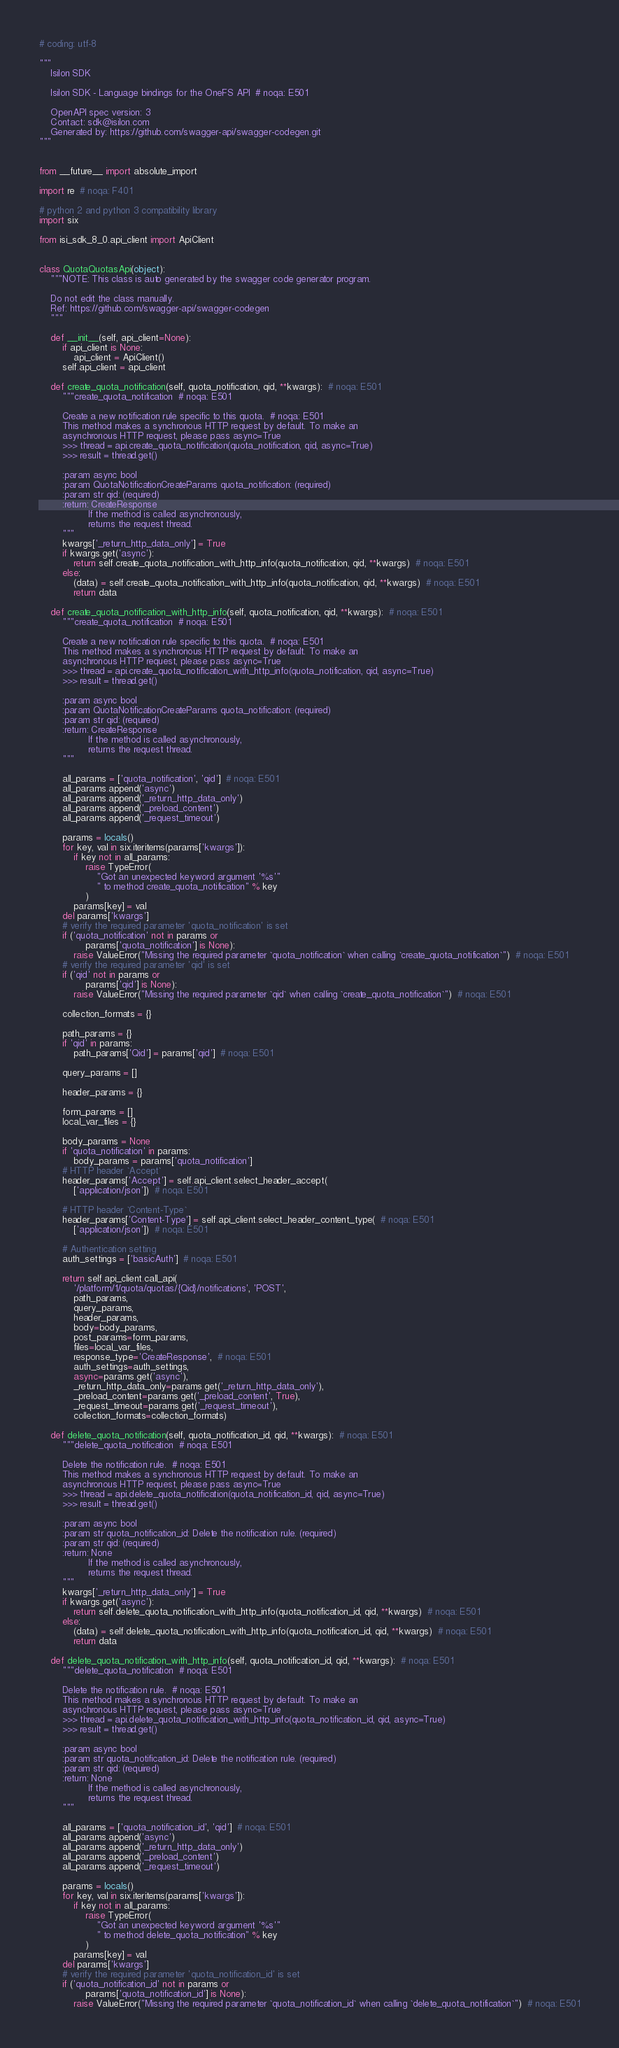Convert code to text. <code><loc_0><loc_0><loc_500><loc_500><_Python_># coding: utf-8

"""
    Isilon SDK

    Isilon SDK - Language bindings for the OneFS API  # noqa: E501

    OpenAPI spec version: 3
    Contact: sdk@isilon.com
    Generated by: https://github.com/swagger-api/swagger-codegen.git
"""


from __future__ import absolute_import

import re  # noqa: F401

# python 2 and python 3 compatibility library
import six

from isi_sdk_8_0.api_client import ApiClient


class QuotaQuotasApi(object):
    """NOTE: This class is auto generated by the swagger code generator program.

    Do not edit the class manually.
    Ref: https://github.com/swagger-api/swagger-codegen
    """

    def __init__(self, api_client=None):
        if api_client is None:
            api_client = ApiClient()
        self.api_client = api_client

    def create_quota_notification(self, quota_notification, qid, **kwargs):  # noqa: E501
        """create_quota_notification  # noqa: E501

        Create a new notification rule specific to this quota.  # noqa: E501
        This method makes a synchronous HTTP request by default. To make an
        asynchronous HTTP request, please pass async=True
        >>> thread = api.create_quota_notification(quota_notification, qid, async=True)
        >>> result = thread.get()

        :param async bool
        :param QuotaNotificationCreateParams quota_notification: (required)
        :param str qid: (required)
        :return: CreateResponse
                 If the method is called asynchronously,
                 returns the request thread.
        """
        kwargs['_return_http_data_only'] = True
        if kwargs.get('async'):
            return self.create_quota_notification_with_http_info(quota_notification, qid, **kwargs)  # noqa: E501
        else:
            (data) = self.create_quota_notification_with_http_info(quota_notification, qid, **kwargs)  # noqa: E501
            return data

    def create_quota_notification_with_http_info(self, quota_notification, qid, **kwargs):  # noqa: E501
        """create_quota_notification  # noqa: E501

        Create a new notification rule specific to this quota.  # noqa: E501
        This method makes a synchronous HTTP request by default. To make an
        asynchronous HTTP request, please pass async=True
        >>> thread = api.create_quota_notification_with_http_info(quota_notification, qid, async=True)
        >>> result = thread.get()

        :param async bool
        :param QuotaNotificationCreateParams quota_notification: (required)
        :param str qid: (required)
        :return: CreateResponse
                 If the method is called asynchronously,
                 returns the request thread.
        """

        all_params = ['quota_notification', 'qid']  # noqa: E501
        all_params.append('async')
        all_params.append('_return_http_data_only')
        all_params.append('_preload_content')
        all_params.append('_request_timeout')

        params = locals()
        for key, val in six.iteritems(params['kwargs']):
            if key not in all_params:
                raise TypeError(
                    "Got an unexpected keyword argument '%s'"
                    " to method create_quota_notification" % key
                )
            params[key] = val
        del params['kwargs']
        # verify the required parameter 'quota_notification' is set
        if ('quota_notification' not in params or
                params['quota_notification'] is None):
            raise ValueError("Missing the required parameter `quota_notification` when calling `create_quota_notification`")  # noqa: E501
        # verify the required parameter 'qid' is set
        if ('qid' not in params or
                params['qid'] is None):
            raise ValueError("Missing the required parameter `qid` when calling `create_quota_notification`")  # noqa: E501

        collection_formats = {}

        path_params = {}
        if 'qid' in params:
            path_params['Qid'] = params['qid']  # noqa: E501

        query_params = []

        header_params = {}

        form_params = []
        local_var_files = {}

        body_params = None
        if 'quota_notification' in params:
            body_params = params['quota_notification']
        # HTTP header `Accept`
        header_params['Accept'] = self.api_client.select_header_accept(
            ['application/json'])  # noqa: E501

        # HTTP header `Content-Type`
        header_params['Content-Type'] = self.api_client.select_header_content_type(  # noqa: E501
            ['application/json'])  # noqa: E501

        # Authentication setting
        auth_settings = ['basicAuth']  # noqa: E501

        return self.api_client.call_api(
            '/platform/1/quota/quotas/{Qid}/notifications', 'POST',
            path_params,
            query_params,
            header_params,
            body=body_params,
            post_params=form_params,
            files=local_var_files,
            response_type='CreateResponse',  # noqa: E501
            auth_settings=auth_settings,
            async=params.get('async'),
            _return_http_data_only=params.get('_return_http_data_only'),
            _preload_content=params.get('_preload_content', True),
            _request_timeout=params.get('_request_timeout'),
            collection_formats=collection_formats)

    def delete_quota_notification(self, quota_notification_id, qid, **kwargs):  # noqa: E501
        """delete_quota_notification  # noqa: E501

        Delete the notification rule.  # noqa: E501
        This method makes a synchronous HTTP request by default. To make an
        asynchronous HTTP request, please pass async=True
        >>> thread = api.delete_quota_notification(quota_notification_id, qid, async=True)
        >>> result = thread.get()

        :param async bool
        :param str quota_notification_id: Delete the notification rule. (required)
        :param str qid: (required)
        :return: None
                 If the method is called asynchronously,
                 returns the request thread.
        """
        kwargs['_return_http_data_only'] = True
        if kwargs.get('async'):
            return self.delete_quota_notification_with_http_info(quota_notification_id, qid, **kwargs)  # noqa: E501
        else:
            (data) = self.delete_quota_notification_with_http_info(quota_notification_id, qid, **kwargs)  # noqa: E501
            return data

    def delete_quota_notification_with_http_info(self, quota_notification_id, qid, **kwargs):  # noqa: E501
        """delete_quota_notification  # noqa: E501

        Delete the notification rule.  # noqa: E501
        This method makes a synchronous HTTP request by default. To make an
        asynchronous HTTP request, please pass async=True
        >>> thread = api.delete_quota_notification_with_http_info(quota_notification_id, qid, async=True)
        >>> result = thread.get()

        :param async bool
        :param str quota_notification_id: Delete the notification rule. (required)
        :param str qid: (required)
        :return: None
                 If the method is called asynchronously,
                 returns the request thread.
        """

        all_params = ['quota_notification_id', 'qid']  # noqa: E501
        all_params.append('async')
        all_params.append('_return_http_data_only')
        all_params.append('_preload_content')
        all_params.append('_request_timeout')

        params = locals()
        for key, val in six.iteritems(params['kwargs']):
            if key not in all_params:
                raise TypeError(
                    "Got an unexpected keyword argument '%s'"
                    " to method delete_quota_notification" % key
                )
            params[key] = val
        del params['kwargs']
        # verify the required parameter 'quota_notification_id' is set
        if ('quota_notification_id' not in params or
                params['quota_notification_id'] is None):
            raise ValueError("Missing the required parameter `quota_notification_id` when calling `delete_quota_notification`")  # noqa: E501</code> 